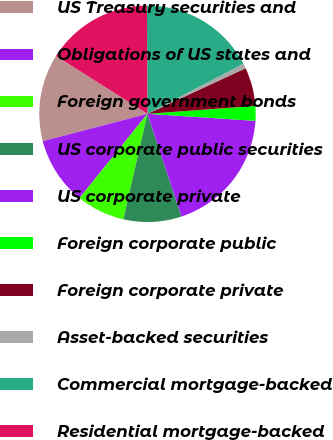Convert chart to OTSL. <chart><loc_0><loc_0><loc_500><loc_500><pie_chart><fcel>US Treasury securities and<fcel>Obligations of US states and<fcel>Foreign government bonds<fcel>US corporate public securities<fcel>US corporate private<fcel>Foreign corporate public<fcel>Foreign corporate private<fcel>Asset-backed securities<fcel>Commercial mortgage-backed<fcel>Residential mortgage-backed<nl><fcel>13.04%<fcel>10.13%<fcel>7.22%<fcel>8.67%<fcel>18.87%<fcel>2.2%<fcel>5.76%<fcel>0.74%<fcel>17.41%<fcel>15.95%<nl></chart> 